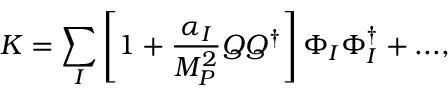<formula> <loc_0><loc_0><loc_500><loc_500>K = \sum _ { I } \left [ 1 + \frac { \alpha _ { I } } { M _ { P } ^ { 2 } } Q Q ^ { \dagger } \right ] \Phi _ { I } \Phi _ { I } ^ { \dagger } + \dots ,</formula> 